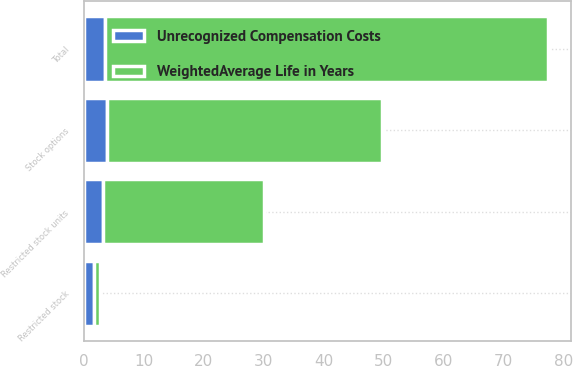<chart> <loc_0><loc_0><loc_500><loc_500><stacked_bar_chart><ecel><fcel>Stock options<fcel>Restricted stock units<fcel>Restricted stock<fcel>Total<nl><fcel>WeightedAverage Life in Years<fcel>46<fcel>27<fcel>1<fcel>74<nl><fcel>Unrecognized Compensation Costs<fcel>3.8<fcel>3.1<fcel>1.7<fcel>3.5<nl></chart> 